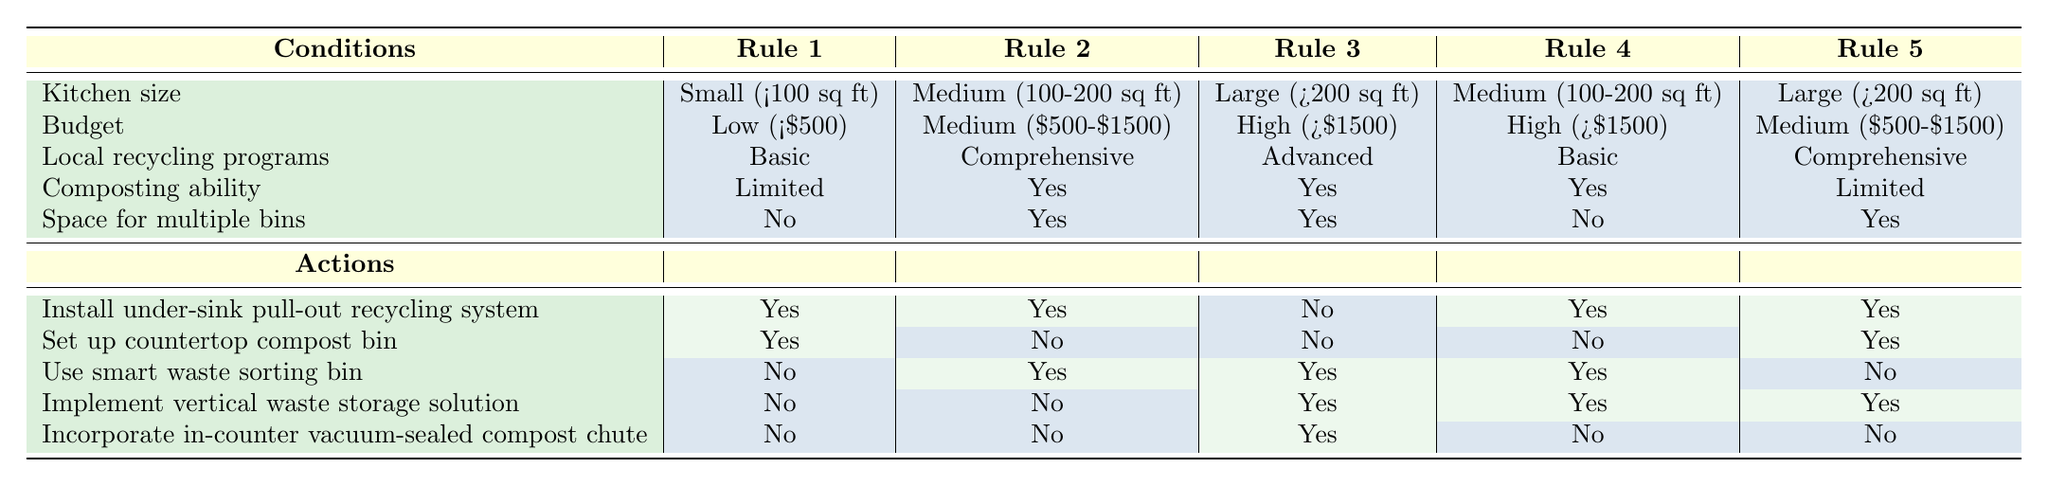What waste management actions are available for a small kitchen with a limited budget? According to Rule 1 in the table, for a small kitchen with a low budget, the actions available are: Install under-sink pull-out recycling system - Yes, Set up countertop compost bin - Yes, Use smart waste sorting bin - No, Implement vertical waste storage solution - No, Incorporate in-counter vacuum-sealed compost chute - No.
Answer: Install under-sink pull-out recycling system, Set up countertop compost bin Which kitchen size allows for the installation of a smart waste sorting bin? The table shows that a smart waste sorting bin can be installed in Rule 2 (Medium kitchen with medium budget), Rule 3 (Large kitchen with high budget), Rule 4 (Medium kitchen with high budget), and it is not allowed in Rule 1 (Small kitchen with low budget) and Rule 5 (Large kitchen with medium budget).
Answer: Medium and Large kitchens How many waste management solutions can be implemented in a large kitchen with advanced local recycling programs? Referring to Rule 3, a large kitchen with advanced recycling programs can implement three waste management solutions: use smart waste sorting bin - Yes, implement vertical waste storage solution - Yes, incorporate in-counter vacuum-sealed compost chute - Yes.
Answer: Three Is it true that a medium-sized kitchen with a basic recycling program can have an in-counter vacuum-sealed compost chute? We can see in Rule 4, which describes a medium-sized kitchen with a basic recycling program, that the in-counter vacuum-sealed compost chute is not available (No).
Answer: No If a kitchen has the ability to compost, what are the possible waste management actions available for a small kitchen? Looking at Rule 1, if a kitchen can compost, it will have limited actions. However, given the limitations of a small kitchen with limited composting ability, the actions available are: Install under-sink pull-out recycling system - Yes, Set up countertop compost bin - Yes, Use smart waste sorting bin - No, Implement vertical waste storage solution - No, Incorporate in-counter vacuum-sealed compost chute - No.
Answer: Install under-sink pull-out recycling system and Set up countertop compost bin What is the most flexible option for waste management in a medium-sized kitchen with a high budget? Reviewing Rule 4 for a medium-sized kitchen with a high budget, the most flexible option involves three solutions: Install under-sink pull-out recycling system - Yes, Use smart waste sorting bin - Yes, Implement vertical waste storage solution - Yes, thus providing the most options for effective waste management.
Answer: Three options (all actions except compost bin) How many total waste management actions are available to a large kitchen with a medium budget? By reviewing Rule 5, we see the available actions for a large kitchen with a medium budget: Install under-sink pull-out recycling system - Yes, Set up countertop compost bin - Yes, Use smart waste sorting bin - No, Implement vertical waste storage solution - Yes, Incorporate in-counter vacuum-sealed compost chute - No, leading to a total of three actions available.
Answer: Three actions 